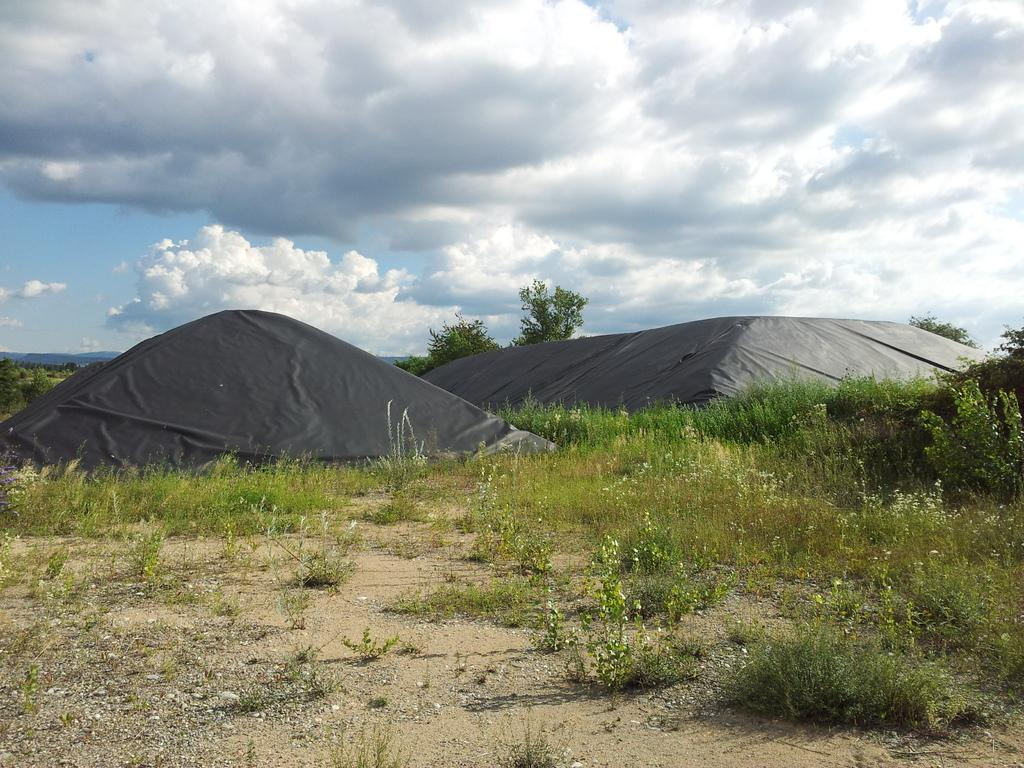What type of surface can be seen in the image? There is ground visible in the image. What color is the grass on the ground? There is green grass on the ground. What objects are placed on the ground? There are black colored sheets on the ground. What can be seen in the background of the image? There are trees and the sky visible in the background of the image. How many clocks are hanging from the trees in the image? There are no clocks visible in the image; it only features trees and the sky in the background. What type of glass is used to make the black sheets in the image? There is no glass mentioned or visible in the image; the black sheets are not made of glass. 